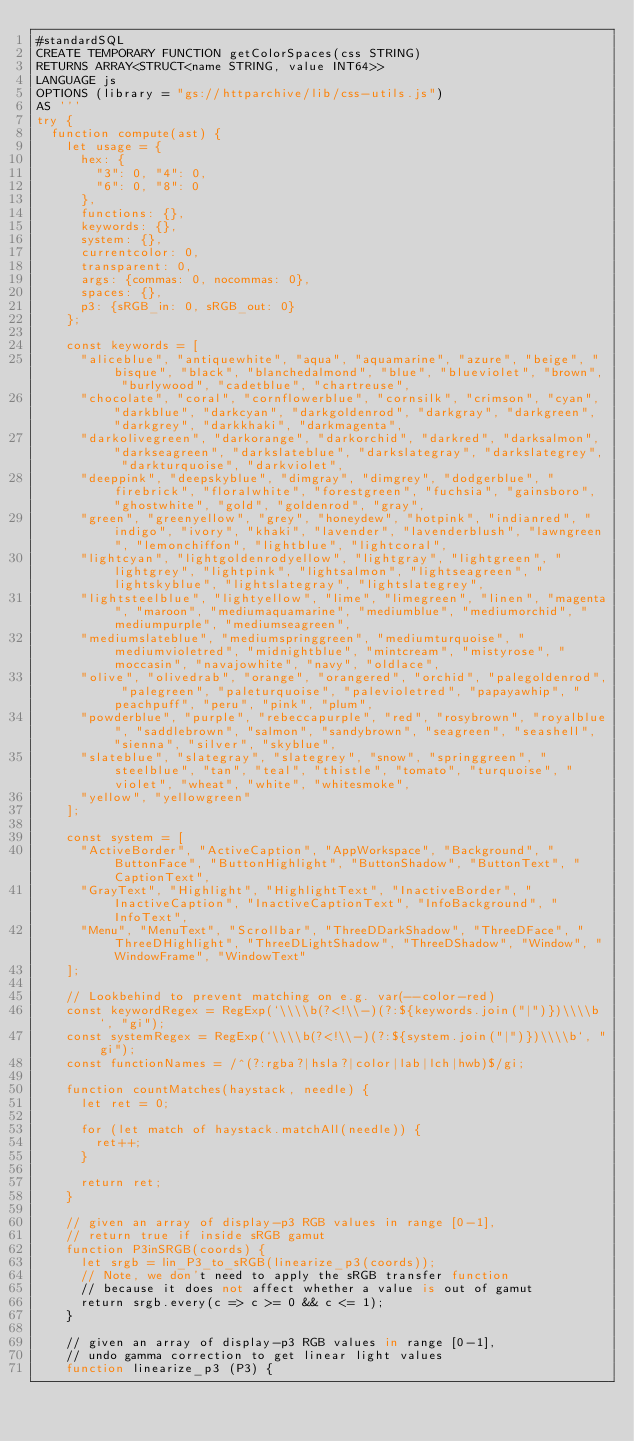Convert code to text. <code><loc_0><loc_0><loc_500><loc_500><_SQL_>#standardSQL
CREATE TEMPORARY FUNCTION getColorSpaces(css STRING)
RETURNS ARRAY<STRUCT<name STRING, value INT64>>
LANGUAGE js
OPTIONS (library = "gs://httparchive/lib/css-utils.js")
AS '''
try {
  function compute(ast) {
    let usage = {
      hex: {
        "3": 0, "4": 0,
        "6": 0, "8": 0
      },
      functions: {},
      keywords: {},
      system: {},
      currentcolor: 0,
      transparent: 0,
      args: {commas: 0, nocommas: 0},
      spaces: {},
      p3: {sRGB_in: 0, sRGB_out: 0}
    };

    const keywords = [
      "aliceblue", "antiquewhite", "aqua", "aquamarine", "azure", "beige", "bisque", "black", "blanchedalmond", "blue", "blueviolet", "brown", "burlywood", "cadetblue", "chartreuse",
      "chocolate", "coral", "cornflowerblue", "cornsilk", "crimson", "cyan", "darkblue", "darkcyan", "darkgoldenrod", "darkgray", "darkgreen", "darkgrey", "darkkhaki", "darkmagenta",
      "darkolivegreen", "darkorange", "darkorchid", "darkred", "darksalmon", "darkseagreen", "darkslateblue", "darkslategray", "darkslategrey", "darkturquoise", "darkviolet",
      "deeppink", "deepskyblue", "dimgray", "dimgrey", "dodgerblue", "firebrick", "floralwhite", "forestgreen", "fuchsia", "gainsboro", "ghostwhite", "gold", "goldenrod", "gray",
      "green", "greenyellow", "grey", "honeydew", "hotpink", "indianred", "indigo", "ivory", "khaki", "lavender", "lavenderblush", "lawngreen", "lemonchiffon", "lightblue", "lightcoral",
      "lightcyan", "lightgoldenrodyellow", "lightgray", "lightgreen", "lightgrey", "lightpink", "lightsalmon", "lightseagreen", "lightskyblue", "lightslategray", "lightslategrey",
      "lightsteelblue", "lightyellow", "lime", "limegreen", "linen", "magenta", "maroon", "mediumaquamarine", "mediumblue", "mediumorchid", "mediumpurple", "mediumseagreen",
      "mediumslateblue", "mediumspringgreen", "mediumturquoise", "mediumvioletred", "midnightblue", "mintcream", "mistyrose", "moccasin", "navajowhite", "navy", "oldlace",
      "olive", "olivedrab", "orange", "orangered", "orchid", "palegoldenrod", "palegreen", "paleturquoise", "palevioletred", "papayawhip", "peachpuff", "peru", "pink", "plum",
      "powderblue", "purple", "rebeccapurple", "red", "rosybrown", "royalblue", "saddlebrown", "salmon", "sandybrown", "seagreen", "seashell", "sienna", "silver", "skyblue",
      "slateblue", "slategray", "slategrey", "snow", "springgreen", "steelblue", "tan", "teal", "thistle", "tomato", "turquoise", "violet", "wheat", "white", "whitesmoke",
      "yellow", "yellowgreen"
    ];

    const system = [
      "ActiveBorder", "ActiveCaption", "AppWorkspace", "Background", "ButtonFace", "ButtonHighlight", "ButtonShadow", "ButtonText", "CaptionText",
      "GrayText", "Highlight", "HighlightText", "InactiveBorder", "InactiveCaption", "InactiveCaptionText", "InfoBackground", "InfoText",
      "Menu", "MenuText", "Scrollbar", "ThreeDDarkShadow", "ThreeDFace", "ThreeDHighlight", "ThreeDLightShadow", "ThreeDShadow", "Window", "WindowFrame", "WindowText"
    ];

    // Lookbehind to prevent matching on e.g. var(--color-red)
    const keywordRegex = RegExp(`\\\\b(?<!\\-)(?:${keywords.join("|")})\\\\b`, "gi");
    const systemRegex = RegExp(`\\\\b(?<!\\-)(?:${system.join("|")})\\\\b`, "gi");
    const functionNames = /^(?:rgba?|hsla?|color|lab|lch|hwb)$/gi;

    function countMatches(haystack, needle) {
      let ret = 0;

      for (let match of haystack.matchAll(needle)) {
        ret++;
      }

      return ret;
    }

    // given an array of display-p3 RGB values in range [0-1],
    // return true if inside sRGB gamut
    function P3inSRGB(coords) {
      let srgb = lin_P3_to_sRGB(linearize_p3(coords));
      // Note, we don't need to apply the sRGB transfer function
      // because it does not affect whether a value is out of gamut
      return srgb.every(c => c >= 0 && c <= 1);
    }

    // given an array of display-p3 RGB values in range [0-1],
    // undo gamma correction to get linear light values
    function linearize_p3 (P3) {</code> 